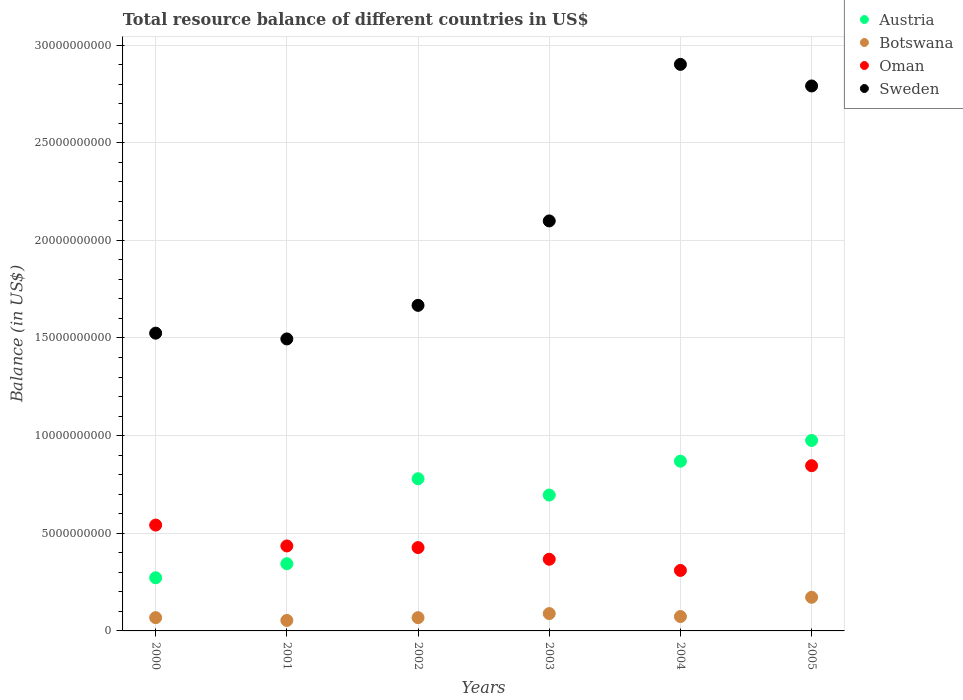What is the total resource balance in Botswana in 2005?
Provide a short and direct response. 1.72e+09. Across all years, what is the maximum total resource balance in Oman?
Your response must be concise. 8.46e+09. Across all years, what is the minimum total resource balance in Austria?
Your answer should be compact. 2.72e+09. In which year was the total resource balance in Botswana minimum?
Keep it short and to the point. 2001. What is the total total resource balance in Oman in the graph?
Your answer should be very brief. 2.93e+1. What is the difference between the total resource balance in Botswana in 2001 and that in 2004?
Your answer should be very brief. -2.00e+08. What is the difference between the total resource balance in Oman in 2003 and the total resource balance in Botswana in 2005?
Provide a succinct answer. 1.95e+09. What is the average total resource balance in Austria per year?
Make the answer very short. 6.56e+09. In the year 2004, what is the difference between the total resource balance in Austria and total resource balance in Botswana?
Your answer should be compact. 7.95e+09. In how many years, is the total resource balance in Oman greater than 5000000000 US$?
Give a very brief answer. 2. What is the ratio of the total resource balance in Austria in 2004 to that in 2005?
Keep it short and to the point. 0.89. Is the total resource balance in Oman in 2001 less than that in 2004?
Your answer should be compact. No. What is the difference between the highest and the second highest total resource balance in Botswana?
Your answer should be very brief. 8.34e+08. What is the difference between the highest and the lowest total resource balance in Sweden?
Offer a very short reply. 1.41e+1. In how many years, is the total resource balance in Sweden greater than the average total resource balance in Sweden taken over all years?
Your answer should be compact. 3. Is the sum of the total resource balance in Botswana in 2001 and 2003 greater than the maximum total resource balance in Sweden across all years?
Make the answer very short. No. Is it the case that in every year, the sum of the total resource balance in Oman and total resource balance in Austria  is greater than the sum of total resource balance in Sweden and total resource balance in Botswana?
Your answer should be very brief. Yes. How many dotlines are there?
Offer a very short reply. 4. What is the difference between two consecutive major ticks on the Y-axis?
Your answer should be very brief. 5.00e+09. Does the graph contain any zero values?
Offer a very short reply. No. How are the legend labels stacked?
Make the answer very short. Vertical. What is the title of the graph?
Offer a very short reply. Total resource balance of different countries in US$. Does "Cote d'Ivoire" appear as one of the legend labels in the graph?
Keep it short and to the point. No. What is the label or title of the Y-axis?
Provide a short and direct response. Balance (in US$). What is the Balance (in US$) in Austria in 2000?
Offer a terse response. 2.72e+09. What is the Balance (in US$) in Botswana in 2000?
Ensure brevity in your answer.  6.79e+08. What is the Balance (in US$) of Oman in 2000?
Offer a terse response. 5.42e+09. What is the Balance (in US$) in Sweden in 2000?
Offer a terse response. 1.52e+1. What is the Balance (in US$) of Austria in 2001?
Offer a very short reply. 3.44e+09. What is the Balance (in US$) in Botswana in 2001?
Provide a short and direct response. 5.37e+08. What is the Balance (in US$) of Oman in 2001?
Provide a short and direct response. 4.35e+09. What is the Balance (in US$) in Sweden in 2001?
Your answer should be compact. 1.50e+1. What is the Balance (in US$) of Austria in 2002?
Keep it short and to the point. 7.79e+09. What is the Balance (in US$) in Botswana in 2002?
Offer a very short reply. 6.79e+08. What is the Balance (in US$) in Oman in 2002?
Ensure brevity in your answer.  4.27e+09. What is the Balance (in US$) of Sweden in 2002?
Your answer should be very brief. 1.67e+1. What is the Balance (in US$) in Austria in 2003?
Your response must be concise. 6.96e+09. What is the Balance (in US$) of Botswana in 2003?
Provide a short and direct response. 8.88e+08. What is the Balance (in US$) of Oman in 2003?
Make the answer very short. 3.67e+09. What is the Balance (in US$) in Sweden in 2003?
Offer a terse response. 2.10e+1. What is the Balance (in US$) in Austria in 2004?
Offer a terse response. 8.69e+09. What is the Balance (in US$) of Botswana in 2004?
Ensure brevity in your answer.  7.37e+08. What is the Balance (in US$) of Oman in 2004?
Provide a short and direct response. 3.10e+09. What is the Balance (in US$) of Sweden in 2004?
Your response must be concise. 2.90e+1. What is the Balance (in US$) in Austria in 2005?
Keep it short and to the point. 9.75e+09. What is the Balance (in US$) of Botswana in 2005?
Make the answer very short. 1.72e+09. What is the Balance (in US$) in Oman in 2005?
Your answer should be very brief. 8.46e+09. What is the Balance (in US$) of Sweden in 2005?
Provide a succinct answer. 2.79e+1. Across all years, what is the maximum Balance (in US$) in Austria?
Make the answer very short. 9.75e+09. Across all years, what is the maximum Balance (in US$) in Botswana?
Offer a terse response. 1.72e+09. Across all years, what is the maximum Balance (in US$) of Oman?
Provide a succinct answer. 8.46e+09. Across all years, what is the maximum Balance (in US$) in Sweden?
Your answer should be very brief. 2.90e+1. Across all years, what is the minimum Balance (in US$) of Austria?
Provide a succinct answer. 2.72e+09. Across all years, what is the minimum Balance (in US$) in Botswana?
Your answer should be very brief. 5.37e+08. Across all years, what is the minimum Balance (in US$) of Oman?
Your answer should be compact. 3.10e+09. Across all years, what is the minimum Balance (in US$) in Sweden?
Provide a succinct answer. 1.50e+1. What is the total Balance (in US$) in Austria in the graph?
Your response must be concise. 3.94e+1. What is the total Balance (in US$) of Botswana in the graph?
Your answer should be very brief. 5.24e+09. What is the total Balance (in US$) of Oman in the graph?
Make the answer very short. 2.93e+1. What is the total Balance (in US$) of Sweden in the graph?
Make the answer very short. 1.25e+11. What is the difference between the Balance (in US$) in Austria in 2000 and that in 2001?
Your answer should be very brief. -7.19e+08. What is the difference between the Balance (in US$) of Botswana in 2000 and that in 2001?
Keep it short and to the point. 1.42e+08. What is the difference between the Balance (in US$) of Oman in 2000 and that in 2001?
Offer a terse response. 1.07e+09. What is the difference between the Balance (in US$) of Sweden in 2000 and that in 2001?
Ensure brevity in your answer.  2.95e+08. What is the difference between the Balance (in US$) of Austria in 2000 and that in 2002?
Your response must be concise. -5.07e+09. What is the difference between the Balance (in US$) of Botswana in 2000 and that in 2002?
Your answer should be compact. 7.66e+05. What is the difference between the Balance (in US$) of Oman in 2000 and that in 2002?
Provide a succinct answer. 1.15e+09. What is the difference between the Balance (in US$) in Sweden in 2000 and that in 2002?
Provide a succinct answer. -1.42e+09. What is the difference between the Balance (in US$) in Austria in 2000 and that in 2003?
Provide a succinct answer. -4.24e+09. What is the difference between the Balance (in US$) of Botswana in 2000 and that in 2003?
Offer a very short reply. -2.08e+08. What is the difference between the Balance (in US$) of Oman in 2000 and that in 2003?
Your answer should be very brief. 1.75e+09. What is the difference between the Balance (in US$) of Sweden in 2000 and that in 2003?
Your response must be concise. -5.75e+09. What is the difference between the Balance (in US$) of Austria in 2000 and that in 2004?
Provide a succinct answer. -5.97e+09. What is the difference between the Balance (in US$) in Botswana in 2000 and that in 2004?
Your answer should be compact. -5.77e+07. What is the difference between the Balance (in US$) of Oman in 2000 and that in 2004?
Ensure brevity in your answer.  2.32e+09. What is the difference between the Balance (in US$) in Sweden in 2000 and that in 2004?
Provide a succinct answer. -1.38e+1. What is the difference between the Balance (in US$) of Austria in 2000 and that in 2005?
Your answer should be compact. -7.03e+09. What is the difference between the Balance (in US$) in Botswana in 2000 and that in 2005?
Make the answer very short. -1.04e+09. What is the difference between the Balance (in US$) of Oman in 2000 and that in 2005?
Offer a terse response. -3.04e+09. What is the difference between the Balance (in US$) of Sweden in 2000 and that in 2005?
Keep it short and to the point. -1.27e+1. What is the difference between the Balance (in US$) of Austria in 2001 and that in 2002?
Your response must be concise. -4.35e+09. What is the difference between the Balance (in US$) in Botswana in 2001 and that in 2002?
Your response must be concise. -1.41e+08. What is the difference between the Balance (in US$) in Oman in 2001 and that in 2002?
Make the answer very short. 8.32e+07. What is the difference between the Balance (in US$) in Sweden in 2001 and that in 2002?
Your answer should be very brief. -1.72e+09. What is the difference between the Balance (in US$) of Austria in 2001 and that in 2003?
Make the answer very short. -3.52e+09. What is the difference between the Balance (in US$) in Botswana in 2001 and that in 2003?
Your response must be concise. -3.50e+08. What is the difference between the Balance (in US$) in Oman in 2001 and that in 2003?
Provide a succinct answer. 6.81e+08. What is the difference between the Balance (in US$) of Sweden in 2001 and that in 2003?
Offer a terse response. -6.04e+09. What is the difference between the Balance (in US$) in Austria in 2001 and that in 2004?
Offer a terse response. -5.25e+09. What is the difference between the Balance (in US$) in Botswana in 2001 and that in 2004?
Provide a succinct answer. -2.00e+08. What is the difference between the Balance (in US$) of Oman in 2001 and that in 2004?
Your answer should be compact. 1.25e+09. What is the difference between the Balance (in US$) in Sweden in 2001 and that in 2004?
Offer a terse response. -1.41e+1. What is the difference between the Balance (in US$) in Austria in 2001 and that in 2005?
Make the answer very short. -6.31e+09. What is the difference between the Balance (in US$) in Botswana in 2001 and that in 2005?
Offer a very short reply. -1.18e+09. What is the difference between the Balance (in US$) of Oman in 2001 and that in 2005?
Make the answer very short. -4.11e+09. What is the difference between the Balance (in US$) of Sweden in 2001 and that in 2005?
Give a very brief answer. -1.30e+1. What is the difference between the Balance (in US$) in Austria in 2002 and that in 2003?
Offer a terse response. 8.34e+08. What is the difference between the Balance (in US$) in Botswana in 2002 and that in 2003?
Keep it short and to the point. -2.09e+08. What is the difference between the Balance (in US$) in Oman in 2002 and that in 2003?
Keep it short and to the point. 5.98e+08. What is the difference between the Balance (in US$) of Sweden in 2002 and that in 2003?
Provide a short and direct response. -4.32e+09. What is the difference between the Balance (in US$) in Austria in 2002 and that in 2004?
Your answer should be compact. -8.99e+08. What is the difference between the Balance (in US$) of Botswana in 2002 and that in 2004?
Your response must be concise. -5.85e+07. What is the difference between the Balance (in US$) in Oman in 2002 and that in 2004?
Provide a succinct answer. 1.17e+09. What is the difference between the Balance (in US$) of Sweden in 2002 and that in 2004?
Your response must be concise. -1.23e+1. What is the difference between the Balance (in US$) in Austria in 2002 and that in 2005?
Ensure brevity in your answer.  -1.96e+09. What is the difference between the Balance (in US$) of Botswana in 2002 and that in 2005?
Give a very brief answer. -1.04e+09. What is the difference between the Balance (in US$) of Oman in 2002 and that in 2005?
Make the answer very short. -4.19e+09. What is the difference between the Balance (in US$) in Sweden in 2002 and that in 2005?
Offer a very short reply. -1.12e+1. What is the difference between the Balance (in US$) of Austria in 2003 and that in 2004?
Offer a very short reply. -1.73e+09. What is the difference between the Balance (in US$) of Botswana in 2003 and that in 2004?
Offer a terse response. 1.51e+08. What is the difference between the Balance (in US$) in Oman in 2003 and that in 2004?
Provide a short and direct response. 5.72e+08. What is the difference between the Balance (in US$) of Sweden in 2003 and that in 2004?
Make the answer very short. -8.02e+09. What is the difference between the Balance (in US$) of Austria in 2003 and that in 2005?
Offer a very short reply. -2.80e+09. What is the difference between the Balance (in US$) in Botswana in 2003 and that in 2005?
Provide a short and direct response. -8.34e+08. What is the difference between the Balance (in US$) of Oman in 2003 and that in 2005?
Your answer should be compact. -4.79e+09. What is the difference between the Balance (in US$) of Sweden in 2003 and that in 2005?
Provide a short and direct response. -6.91e+09. What is the difference between the Balance (in US$) in Austria in 2004 and that in 2005?
Your response must be concise. -1.06e+09. What is the difference between the Balance (in US$) of Botswana in 2004 and that in 2005?
Your answer should be very brief. -9.85e+08. What is the difference between the Balance (in US$) in Oman in 2004 and that in 2005?
Your answer should be compact. -5.36e+09. What is the difference between the Balance (in US$) in Sweden in 2004 and that in 2005?
Make the answer very short. 1.11e+09. What is the difference between the Balance (in US$) of Austria in 2000 and the Balance (in US$) of Botswana in 2001?
Your response must be concise. 2.18e+09. What is the difference between the Balance (in US$) in Austria in 2000 and the Balance (in US$) in Oman in 2001?
Keep it short and to the point. -1.63e+09. What is the difference between the Balance (in US$) in Austria in 2000 and the Balance (in US$) in Sweden in 2001?
Provide a short and direct response. -1.22e+1. What is the difference between the Balance (in US$) of Botswana in 2000 and the Balance (in US$) of Oman in 2001?
Your answer should be compact. -3.67e+09. What is the difference between the Balance (in US$) of Botswana in 2000 and the Balance (in US$) of Sweden in 2001?
Your answer should be compact. -1.43e+1. What is the difference between the Balance (in US$) of Oman in 2000 and the Balance (in US$) of Sweden in 2001?
Your answer should be compact. -9.53e+09. What is the difference between the Balance (in US$) of Austria in 2000 and the Balance (in US$) of Botswana in 2002?
Provide a short and direct response. 2.04e+09. What is the difference between the Balance (in US$) in Austria in 2000 and the Balance (in US$) in Oman in 2002?
Your response must be concise. -1.55e+09. What is the difference between the Balance (in US$) in Austria in 2000 and the Balance (in US$) in Sweden in 2002?
Provide a succinct answer. -1.39e+1. What is the difference between the Balance (in US$) of Botswana in 2000 and the Balance (in US$) of Oman in 2002?
Give a very brief answer. -3.59e+09. What is the difference between the Balance (in US$) of Botswana in 2000 and the Balance (in US$) of Sweden in 2002?
Your answer should be very brief. -1.60e+1. What is the difference between the Balance (in US$) in Oman in 2000 and the Balance (in US$) in Sweden in 2002?
Your response must be concise. -1.13e+1. What is the difference between the Balance (in US$) in Austria in 2000 and the Balance (in US$) in Botswana in 2003?
Offer a terse response. 1.83e+09. What is the difference between the Balance (in US$) of Austria in 2000 and the Balance (in US$) of Oman in 2003?
Keep it short and to the point. -9.48e+08. What is the difference between the Balance (in US$) in Austria in 2000 and the Balance (in US$) in Sweden in 2003?
Provide a succinct answer. -1.83e+1. What is the difference between the Balance (in US$) of Botswana in 2000 and the Balance (in US$) of Oman in 2003?
Ensure brevity in your answer.  -2.99e+09. What is the difference between the Balance (in US$) of Botswana in 2000 and the Balance (in US$) of Sweden in 2003?
Make the answer very short. -2.03e+1. What is the difference between the Balance (in US$) in Oman in 2000 and the Balance (in US$) in Sweden in 2003?
Give a very brief answer. -1.56e+1. What is the difference between the Balance (in US$) in Austria in 2000 and the Balance (in US$) in Botswana in 2004?
Your response must be concise. 1.98e+09. What is the difference between the Balance (in US$) of Austria in 2000 and the Balance (in US$) of Oman in 2004?
Provide a succinct answer. -3.76e+08. What is the difference between the Balance (in US$) of Austria in 2000 and the Balance (in US$) of Sweden in 2004?
Keep it short and to the point. -2.63e+1. What is the difference between the Balance (in US$) of Botswana in 2000 and the Balance (in US$) of Oman in 2004?
Make the answer very short. -2.42e+09. What is the difference between the Balance (in US$) of Botswana in 2000 and the Balance (in US$) of Sweden in 2004?
Keep it short and to the point. -2.83e+1. What is the difference between the Balance (in US$) of Oman in 2000 and the Balance (in US$) of Sweden in 2004?
Your answer should be very brief. -2.36e+1. What is the difference between the Balance (in US$) in Austria in 2000 and the Balance (in US$) in Botswana in 2005?
Provide a succinct answer. 9.99e+08. What is the difference between the Balance (in US$) in Austria in 2000 and the Balance (in US$) in Oman in 2005?
Ensure brevity in your answer.  -5.74e+09. What is the difference between the Balance (in US$) of Austria in 2000 and the Balance (in US$) of Sweden in 2005?
Ensure brevity in your answer.  -2.52e+1. What is the difference between the Balance (in US$) of Botswana in 2000 and the Balance (in US$) of Oman in 2005?
Offer a very short reply. -7.78e+09. What is the difference between the Balance (in US$) of Botswana in 2000 and the Balance (in US$) of Sweden in 2005?
Give a very brief answer. -2.72e+1. What is the difference between the Balance (in US$) in Oman in 2000 and the Balance (in US$) in Sweden in 2005?
Ensure brevity in your answer.  -2.25e+1. What is the difference between the Balance (in US$) in Austria in 2001 and the Balance (in US$) in Botswana in 2002?
Make the answer very short. 2.76e+09. What is the difference between the Balance (in US$) in Austria in 2001 and the Balance (in US$) in Oman in 2002?
Ensure brevity in your answer.  -8.27e+08. What is the difference between the Balance (in US$) in Austria in 2001 and the Balance (in US$) in Sweden in 2002?
Keep it short and to the point. -1.32e+1. What is the difference between the Balance (in US$) in Botswana in 2001 and the Balance (in US$) in Oman in 2002?
Your answer should be compact. -3.73e+09. What is the difference between the Balance (in US$) in Botswana in 2001 and the Balance (in US$) in Sweden in 2002?
Your answer should be compact. -1.61e+1. What is the difference between the Balance (in US$) in Oman in 2001 and the Balance (in US$) in Sweden in 2002?
Offer a terse response. -1.23e+1. What is the difference between the Balance (in US$) of Austria in 2001 and the Balance (in US$) of Botswana in 2003?
Your answer should be very brief. 2.55e+09. What is the difference between the Balance (in US$) in Austria in 2001 and the Balance (in US$) in Oman in 2003?
Your answer should be very brief. -2.29e+08. What is the difference between the Balance (in US$) of Austria in 2001 and the Balance (in US$) of Sweden in 2003?
Provide a short and direct response. -1.76e+1. What is the difference between the Balance (in US$) of Botswana in 2001 and the Balance (in US$) of Oman in 2003?
Make the answer very short. -3.13e+09. What is the difference between the Balance (in US$) in Botswana in 2001 and the Balance (in US$) in Sweden in 2003?
Keep it short and to the point. -2.05e+1. What is the difference between the Balance (in US$) in Oman in 2001 and the Balance (in US$) in Sweden in 2003?
Your answer should be compact. -1.66e+1. What is the difference between the Balance (in US$) of Austria in 2001 and the Balance (in US$) of Botswana in 2004?
Offer a very short reply. 2.70e+09. What is the difference between the Balance (in US$) in Austria in 2001 and the Balance (in US$) in Oman in 2004?
Give a very brief answer. 3.43e+08. What is the difference between the Balance (in US$) of Austria in 2001 and the Balance (in US$) of Sweden in 2004?
Provide a succinct answer. -2.56e+1. What is the difference between the Balance (in US$) in Botswana in 2001 and the Balance (in US$) in Oman in 2004?
Provide a short and direct response. -2.56e+09. What is the difference between the Balance (in US$) of Botswana in 2001 and the Balance (in US$) of Sweden in 2004?
Your response must be concise. -2.85e+1. What is the difference between the Balance (in US$) of Oman in 2001 and the Balance (in US$) of Sweden in 2004?
Provide a short and direct response. -2.47e+1. What is the difference between the Balance (in US$) of Austria in 2001 and the Balance (in US$) of Botswana in 2005?
Offer a very short reply. 1.72e+09. What is the difference between the Balance (in US$) of Austria in 2001 and the Balance (in US$) of Oman in 2005?
Your response must be concise. -5.02e+09. What is the difference between the Balance (in US$) of Austria in 2001 and the Balance (in US$) of Sweden in 2005?
Your response must be concise. -2.45e+1. What is the difference between the Balance (in US$) of Botswana in 2001 and the Balance (in US$) of Oman in 2005?
Give a very brief answer. -7.92e+09. What is the difference between the Balance (in US$) of Botswana in 2001 and the Balance (in US$) of Sweden in 2005?
Keep it short and to the point. -2.74e+1. What is the difference between the Balance (in US$) in Oman in 2001 and the Balance (in US$) in Sweden in 2005?
Your response must be concise. -2.36e+1. What is the difference between the Balance (in US$) in Austria in 2002 and the Balance (in US$) in Botswana in 2003?
Your answer should be compact. 6.90e+09. What is the difference between the Balance (in US$) in Austria in 2002 and the Balance (in US$) in Oman in 2003?
Provide a short and direct response. 4.12e+09. What is the difference between the Balance (in US$) of Austria in 2002 and the Balance (in US$) of Sweden in 2003?
Give a very brief answer. -1.32e+1. What is the difference between the Balance (in US$) in Botswana in 2002 and the Balance (in US$) in Oman in 2003?
Give a very brief answer. -2.99e+09. What is the difference between the Balance (in US$) of Botswana in 2002 and the Balance (in US$) of Sweden in 2003?
Provide a succinct answer. -2.03e+1. What is the difference between the Balance (in US$) in Oman in 2002 and the Balance (in US$) in Sweden in 2003?
Provide a short and direct response. -1.67e+1. What is the difference between the Balance (in US$) of Austria in 2002 and the Balance (in US$) of Botswana in 2004?
Your answer should be compact. 7.05e+09. What is the difference between the Balance (in US$) of Austria in 2002 and the Balance (in US$) of Oman in 2004?
Your response must be concise. 4.69e+09. What is the difference between the Balance (in US$) of Austria in 2002 and the Balance (in US$) of Sweden in 2004?
Give a very brief answer. -2.12e+1. What is the difference between the Balance (in US$) of Botswana in 2002 and the Balance (in US$) of Oman in 2004?
Provide a short and direct response. -2.42e+09. What is the difference between the Balance (in US$) in Botswana in 2002 and the Balance (in US$) in Sweden in 2004?
Make the answer very short. -2.83e+1. What is the difference between the Balance (in US$) of Oman in 2002 and the Balance (in US$) of Sweden in 2004?
Give a very brief answer. -2.47e+1. What is the difference between the Balance (in US$) in Austria in 2002 and the Balance (in US$) in Botswana in 2005?
Ensure brevity in your answer.  6.07e+09. What is the difference between the Balance (in US$) in Austria in 2002 and the Balance (in US$) in Oman in 2005?
Make the answer very short. -6.69e+08. What is the difference between the Balance (in US$) of Austria in 2002 and the Balance (in US$) of Sweden in 2005?
Give a very brief answer. -2.01e+1. What is the difference between the Balance (in US$) of Botswana in 2002 and the Balance (in US$) of Oman in 2005?
Ensure brevity in your answer.  -7.78e+09. What is the difference between the Balance (in US$) of Botswana in 2002 and the Balance (in US$) of Sweden in 2005?
Offer a very short reply. -2.72e+1. What is the difference between the Balance (in US$) in Oman in 2002 and the Balance (in US$) in Sweden in 2005?
Your answer should be compact. -2.36e+1. What is the difference between the Balance (in US$) in Austria in 2003 and the Balance (in US$) in Botswana in 2004?
Offer a terse response. 6.22e+09. What is the difference between the Balance (in US$) in Austria in 2003 and the Balance (in US$) in Oman in 2004?
Keep it short and to the point. 3.86e+09. What is the difference between the Balance (in US$) in Austria in 2003 and the Balance (in US$) in Sweden in 2004?
Offer a very short reply. -2.21e+1. What is the difference between the Balance (in US$) in Botswana in 2003 and the Balance (in US$) in Oman in 2004?
Offer a terse response. -2.21e+09. What is the difference between the Balance (in US$) in Botswana in 2003 and the Balance (in US$) in Sweden in 2004?
Offer a terse response. -2.81e+1. What is the difference between the Balance (in US$) in Oman in 2003 and the Balance (in US$) in Sweden in 2004?
Your answer should be compact. -2.53e+1. What is the difference between the Balance (in US$) in Austria in 2003 and the Balance (in US$) in Botswana in 2005?
Your response must be concise. 5.24e+09. What is the difference between the Balance (in US$) in Austria in 2003 and the Balance (in US$) in Oman in 2005?
Ensure brevity in your answer.  -1.50e+09. What is the difference between the Balance (in US$) of Austria in 2003 and the Balance (in US$) of Sweden in 2005?
Ensure brevity in your answer.  -2.09e+1. What is the difference between the Balance (in US$) of Botswana in 2003 and the Balance (in US$) of Oman in 2005?
Your answer should be very brief. -7.57e+09. What is the difference between the Balance (in US$) of Botswana in 2003 and the Balance (in US$) of Sweden in 2005?
Keep it short and to the point. -2.70e+1. What is the difference between the Balance (in US$) in Oman in 2003 and the Balance (in US$) in Sweden in 2005?
Offer a very short reply. -2.42e+1. What is the difference between the Balance (in US$) of Austria in 2004 and the Balance (in US$) of Botswana in 2005?
Your response must be concise. 6.97e+09. What is the difference between the Balance (in US$) in Austria in 2004 and the Balance (in US$) in Oman in 2005?
Offer a very short reply. 2.30e+08. What is the difference between the Balance (in US$) of Austria in 2004 and the Balance (in US$) of Sweden in 2005?
Your answer should be compact. -1.92e+1. What is the difference between the Balance (in US$) of Botswana in 2004 and the Balance (in US$) of Oman in 2005?
Provide a succinct answer. -7.72e+09. What is the difference between the Balance (in US$) of Botswana in 2004 and the Balance (in US$) of Sweden in 2005?
Your response must be concise. -2.72e+1. What is the difference between the Balance (in US$) in Oman in 2004 and the Balance (in US$) in Sweden in 2005?
Your answer should be very brief. -2.48e+1. What is the average Balance (in US$) of Austria per year?
Provide a short and direct response. 6.56e+09. What is the average Balance (in US$) of Botswana per year?
Ensure brevity in your answer.  8.74e+08. What is the average Balance (in US$) in Oman per year?
Keep it short and to the point. 4.88e+09. What is the average Balance (in US$) of Sweden per year?
Ensure brevity in your answer.  2.08e+1. In the year 2000, what is the difference between the Balance (in US$) of Austria and Balance (in US$) of Botswana?
Ensure brevity in your answer.  2.04e+09. In the year 2000, what is the difference between the Balance (in US$) of Austria and Balance (in US$) of Oman?
Your answer should be very brief. -2.70e+09. In the year 2000, what is the difference between the Balance (in US$) in Austria and Balance (in US$) in Sweden?
Offer a terse response. -1.25e+1. In the year 2000, what is the difference between the Balance (in US$) in Botswana and Balance (in US$) in Oman?
Your answer should be compact. -4.74e+09. In the year 2000, what is the difference between the Balance (in US$) in Botswana and Balance (in US$) in Sweden?
Make the answer very short. -1.46e+1. In the year 2000, what is the difference between the Balance (in US$) in Oman and Balance (in US$) in Sweden?
Provide a short and direct response. -9.83e+09. In the year 2001, what is the difference between the Balance (in US$) of Austria and Balance (in US$) of Botswana?
Provide a succinct answer. 2.90e+09. In the year 2001, what is the difference between the Balance (in US$) of Austria and Balance (in US$) of Oman?
Offer a terse response. -9.10e+08. In the year 2001, what is the difference between the Balance (in US$) of Austria and Balance (in US$) of Sweden?
Offer a terse response. -1.15e+1. In the year 2001, what is the difference between the Balance (in US$) of Botswana and Balance (in US$) of Oman?
Provide a succinct answer. -3.81e+09. In the year 2001, what is the difference between the Balance (in US$) of Botswana and Balance (in US$) of Sweden?
Offer a terse response. -1.44e+1. In the year 2001, what is the difference between the Balance (in US$) in Oman and Balance (in US$) in Sweden?
Ensure brevity in your answer.  -1.06e+1. In the year 2002, what is the difference between the Balance (in US$) in Austria and Balance (in US$) in Botswana?
Offer a terse response. 7.11e+09. In the year 2002, what is the difference between the Balance (in US$) of Austria and Balance (in US$) of Oman?
Ensure brevity in your answer.  3.52e+09. In the year 2002, what is the difference between the Balance (in US$) of Austria and Balance (in US$) of Sweden?
Your response must be concise. -8.88e+09. In the year 2002, what is the difference between the Balance (in US$) in Botswana and Balance (in US$) in Oman?
Offer a terse response. -3.59e+09. In the year 2002, what is the difference between the Balance (in US$) of Botswana and Balance (in US$) of Sweden?
Provide a succinct answer. -1.60e+1. In the year 2002, what is the difference between the Balance (in US$) in Oman and Balance (in US$) in Sweden?
Ensure brevity in your answer.  -1.24e+1. In the year 2003, what is the difference between the Balance (in US$) of Austria and Balance (in US$) of Botswana?
Provide a succinct answer. 6.07e+09. In the year 2003, what is the difference between the Balance (in US$) of Austria and Balance (in US$) of Oman?
Provide a succinct answer. 3.29e+09. In the year 2003, what is the difference between the Balance (in US$) in Austria and Balance (in US$) in Sweden?
Give a very brief answer. -1.40e+1. In the year 2003, what is the difference between the Balance (in US$) of Botswana and Balance (in US$) of Oman?
Make the answer very short. -2.78e+09. In the year 2003, what is the difference between the Balance (in US$) of Botswana and Balance (in US$) of Sweden?
Your response must be concise. -2.01e+1. In the year 2003, what is the difference between the Balance (in US$) of Oman and Balance (in US$) of Sweden?
Your response must be concise. -1.73e+1. In the year 2004, what is the difference between the Balance (in US$) in Austria and Balance (in US$) in Botswana?
Your response must be concise. 7.95e+09. In the year 2004, what is the difference between the Balance (in US$) in Austria and Balance (in US$) in Oman?
Ensure brevity in your answer.  5.59e+09. In the year 2004, what is the difference between the Balance (in US$) of Austria and Balance (in US$) of Sweden?
Your response must be concise. -2.03e+1. In the year 2004, what is the difference between the Balance (in US$) of Botswana and Balance (in US$) of Oman?
Your answer should be compact. -2.36e+09. In the year 2004, what is the difference between the Balance (in US$) in Botswana and Balance (in US$) in Sweden?
Give a very brief answer. -2.83e+1. In the year 2004, what is the difference between the Balance (in US$) in Oman and Balance (in US$) in Sweden?
Offer a terse response. -2.59e+1. In the year 2005, what is the difference between the Balance (in US$) of Austria and Balance (in US$) of Botswana?
Your answer should be compact. 8.03e+09. In the year 2005, what is the difference between the Balance (in US$) of Austria and Balance (in US$) of Oman?
Provide a short and direct response. 1.29e+09. In the year 2005, what is the difference between the Balance (in US$) of Austria and Balance (in US$) of Sweden?
Ensure brevity in your answer.  -1.82e+1. In the year 2005, what is the difference between the Balance (in US$) in Botswana and Balance (in US$) in Oman?
Ensure brevity in your answer.  -6.74e+09. In the year 2005, what is the difference between the Balance (in US$) of Botswana and Balance (in US$) of Sweden?
Your response must be concise. -2.62e+1. In the year 2005, what is the difference between the Balance (in US$) in Oman and Balance (in US$) in Sweden?
Provide a succinct answer. -1.94e+1. What is the ratio of the Balance (in US$) in Austria in 2000 to that in 2001?
Your response must be concise. 0.79. What is the ratio of the Balance (in US$) in Botswana in 2000 to that in 2001?
Ensure brevity in your answer.  1.26. What is the ratio of the Balance (in US$) of Oman in 2000 to that in 2001?
Your answer should be compact. 1.25. What is the ratio of the Balance (in US$) of Sweden in 2000 to that in 2001?
Your response must be concise. 1.02. What is the ratio of the Balance (in US$) of Austria in 2000 to that in 2002?
Give a very brief answer. 0.35. What is the ratio of the Balance (in US$) in Botswana in 2000 to that in 2002?
Your answer should be very brief. 1. What is the ratio of the Balance (in US$) of Oman in 2000 to that in 2002?
Your response must be concise. 1.27. What is the ratio of the Balance (in US$) of Sweden in 2000 to that in 2002?
Keep it short and to the point. 0.91. What is the ratio of the Balance (in US$) of Austria in 2000 to that in 2003?
Your answer should be very brief. 0.39. What is the ratio of the Balance (in US$) of Botswana in 2000 to that in 2003?
Your response must be concise. 0.77. What is the ratio of the Balance (in US$) of Oman in 2000 to that in 2003?
Make the answer very short. 1.48. What is the ratio of the Balance (in US$) of Sweden in 2000 to that in 2003?
Your response must be concise. 0.73. What is the ratio of the Balance (in US$) in Austria in 2000 to that in 2004?
Offer a very short reply. 0.31. What is the ratio of the Balance (in US$) of Botswana in 2000 to that in 2004?
Offer a very short reply. 0.92. What is the ratio of the Balance (in US$) in Oman in 2000 to that in 2004?
Your response must be concise. 1.75. What is the ratio of the Balance (in US$) in Sweden in 2000 to that in 2004?
Offer a terse response. 0.53. What is the ratio of the Balance (in US$) in Austria in 2000 to that in 2005?
Give a very brief answer. 0.28. What is the ratio of the Balance (in US$) in Botswana in 2000 to that in 2005?
Provide a succinct answer. 0.39. What is the ratio of the Balance (in US$) in Oman in 2000 to that in 2005?
Ensure brevity in your answer.  0.64. What is the ratio of the Balance (in US$) of Sweden in 2000 to that in 2005?
Give a very brief answer. 0.55. What is the ratio of the Balance (in US$) in Austria in 2001 to that in 2002?
Your response must be concise. 0.44. What is the ratio of the Balance (in US$) in Botswana in 2001 to that in 2002?
Provide a succinct answer. 0.79. What is the ratio of the Balance (in US$) in Oman in 2001 to that in 2002?
Your answer should be compact. 1.02. What is the ratio of the Balance (in US$) of Sweden in 2001 to that in 2002?
Your answer should be compact. 0.9. What is the ratio of the Balance (in US$) in Austria in 2001 to that in 2003?
Ensure brevity in your answer.  0.49. What is the ratio of the Balance (in US$) in Botswana in 2001 to that in 2003?
Give a very brief answer. 0.61. What is the ratio of the Balance (in US$) of Oman in 2001 to that in 2003?
Offer a very short reply. 1.19. What is the ratio of the Balance (in US$) in Sweden in 2001 to that in 2003?
Provide a short and direct response. 0.71. What is the ratio of the Balance (in US$) of Austria in 2001 to that in 2004?
Offer a very short reply. 0.4. What is the ratio of the Balance (in US$) of Botswana in 2001 to that in 2004?
Make the answer very short. 0.73. What is the ratio of the Balance (in US$) in Oman in 2001 to that in 2004?
Your response must be concise. 1.4. What is the ratio of the Balance (in US$) of Sweden in 2001 to that in 2004?
Your answer should be compact. 0.52. What is the ratio of the Balance (in US$) in Austria in 2001 to that in 2005?
Your answer should be very brief. 0.35. What is the ratio of the Balance (in US$) of Botswana in 2001 to that in 2005?
Offer a very short reply. 0.31. What is the ratio of the Balance (in US$) of Oman in 2001 to that in 2005?
Give a very brief answer. 0.51. What is the ratio of the Balance (in US$) in Sweden in 2001 to that in 2005?
Offer a terse response. 0.54. What is the ratio of the Balance (in US$) of Austria in 2002 to that in 2003?
Provide a succinct answer. 1.12. What is the ratio of the Balance (in US$) of Botswana in 2002 to that in 2003?
Your response must be concise. 0.76. What is the ratio of the Balance (in US$) of Oman in 2002 to that in 2003?
Your answer should be compact. 1.16. What is the ratio of the Balance (in US$) in Sweden in 2002 to that in 2003?
Offer a terse response. 0.79. What is the ratio of the Balance (in US$) in Austria in 2002 to that in 2004?
Make the answer very short. 0.9. What is the ratio of the Balance (in US$) in Botswana in 2002 to that in 2004?
Provide a succinct answer. 0.92. What is the ratio of the Balance (in US$) of Oman in 2002 to that in 2004?
Ensure brevity in your answer.  1.38. What is the ratio of the Balance (in US$) of Sweden in 2002 to that in 2004?
Your answer should be compact. 0.57. What is the ratio of the Balance (in US$) in Austria in 2002 to that in 2005?
Provide a short and direct response. 0.8. What is the ratio of the Balance (in US$) of Botswana in 2002 to that in 2005?
Your answer should be compact. 0.39. What is the ratio of the Balance (in US$) of Oman in 2002 to that in 2005?
Your response must be concise. 0.5. What is the ratio of the Balance (in US$) of Sweden in 2002 to that in 2005?
Ensure brevity in your answer.  0.6. What is the ratio of the Balance (in US$) in Austria in 2003 to that in 2004?
Keep it short and to the point. 0.8. What is the ratio of the Balance (in US$) of Botswana in 2003 to that in 2004?
Keep it short and to the point. 1.2. What is the ratio of the Balance (in US$) in Oman in 2003 to that in 2004?
Ensure brevity in your answer.  1.18. What is the ratio of the Balance (in US$) in Sweden in 2003 to that in 2004?
Provide a succinct answer. 0.72. What is the ratio of the Balance (in US$) of Austria in 2003 to that in 2005?
Your answer should be compact. 0.71. What is the ratio of the Balance (in US$) of Botswana in 2003 to that in 2005?
Ensure brevity in your answer.  0.52. What is the ratio of the Balance (in US$) in Oman in 2003 to that in 2005?
Your answer should be compact. 0.43. What is the ratio of the Balance (in US$) of Sweden in 2003 to that in 2005?
Give a very brief answer. 0.75. What is the ratio of the Balance (in US$) of Austria in 2004 to that in 2005?
Your answer should be compact. 0.89. What is the ratio of the Balance (in US$) in Botswana in 2004 to that in 2005?
Give a very brief answer. 0.43. What is the ratio of the Balance (in US$) of Oman in 2004 to that in 2005?
Give a very brief answer. 0.37. What is the ratio of the Balance (in US$) in Sweden in 2004 to that in 2005?
Provide a succinct answer. 1.04. What is the difference between the highest and the second highest Balance (in US$) of Austria?
Your answer should be very brief. 1.06e+09. What is the difference between the highest and the second highest Balance (in US$) of Botswana?
Ensure brevity in your answer.  8.34e+08. What is the difference between the highest and the second highest Balance (in US$) in Oman?
Give a very brief answer. 3.04e+09. What is the difference between the highest and the second highest Balance (in US$) of Sweden?
Offer a very short reply. 1.11e+09. What is the difference between the highest and the lowest Balance (in US$) in Austria?
Your response must be concise. 7.03e+09. What is the difference between the highest and the lowest Balance (in US$) of Botswana?
Keep it short and to the point. 1.18e+09. What is the difference between the highest and the lowest Balance (in US$) in Oman?
Provide a succinct answer. 5.36e+09. What is the difference between the highest and the lowest Balance (in US$) of Sweden?
Ensure brevity in your answer.  1.41e+1. 